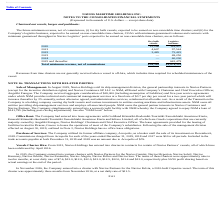According to Navios Maritime Holdings's financial document, What was the future minimum revenue for dry bulk vessels in 2020? According to the financial document, 22,266 (in thousands). The relevant text states: "2020 22,266 129,437..." Also, What was the future minimum revenue for Logistics business in 2021? According to the financial document, 97,544 (in thousands). The relevant text states: "2021 4,607 97,544..." Also, What was the Total minimum revenue, net of commissions for dry bulk vessels? According to the financial document, 30,318 (in thousands). The relevant text states: "Total minimum revenue, net of commissions $30,318 $1,074,335..." Also, can you calculate: What was the difference in the total minimum revenue between dry bulk vessels and logistics business? Based on the calculation: 1,074,335-30,318, the result is 1044017 (in thousands). This is based on the information: "Total minimum revenue, net of commissions $30,318 $1,074,335 otal minimum revenue, net of commissions $30,318 $1,074,335..." The key data points involved are: 1,074,335, 30,318. Also, can you calculate: What was the difference in the minimum revenue from dry bulk vessels between 2020 and 2021? Based on the calculation: 22,266-4,607, the result is 17659 (in thousands). This is based on the information: "2021 4,607 97,544 2020 22,266 129,437..." The key data points involved are: 22,266, 4,607. Also, can you calculate: What was the difference in the minimum revenue for logistics business between 2022 and 2023? Based on the calculation: 75,425-69,250, the result is 6175 (in thousands). This is based on the information: "2023 — 69,250 2022 3,445 75,425..." The key data points involved are: 69,250, 75,425. 